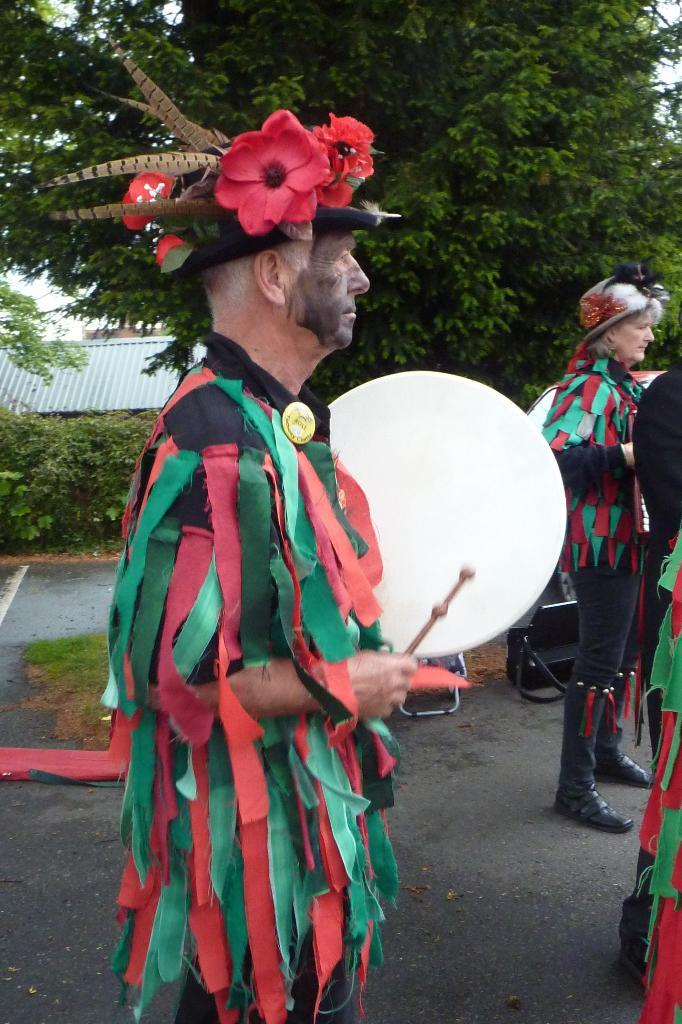What is the main subject of the image? The main subject of the image is a man. What is the man holding in his hands? The man is holding drums in his hands. What is the man wearing on his head? The man is wearing a crown on his head. What can be seen in the background of the image? There are trees and a building in the background of the image. What type of chair is the man sitting on in the image? There is no chair present in the image; the man is standing while holding drums and wearing a crown. What does the man expect to have for lunch in the image? There is no information about lunch in the image; it focuses on the man holding drums and wearing a crown. 